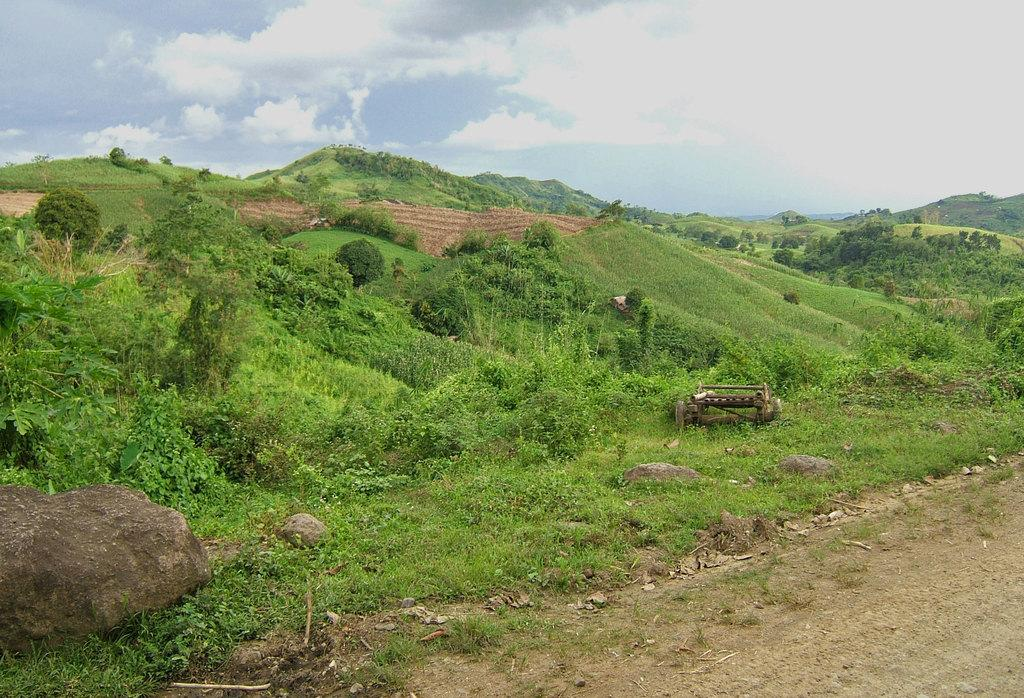What type of surface can be seen in the image? There is a path in the image. What object is present in the image that might be used for transportation? There is a cart in the image. What type of natural elements are visible in the image? There are plants, rocks, grass, hills, and trees in the image. What part of the natural environment is visible in the background of the image? The sky is visible in the background of the image. What type of profit can be seen in the image? There is no mention of profit in the image; it features a path, cart, plants, rocks, grass, hills, trees, and a visible sky. Is there a monkey present in the image? No, there is no monkey present in the image. 